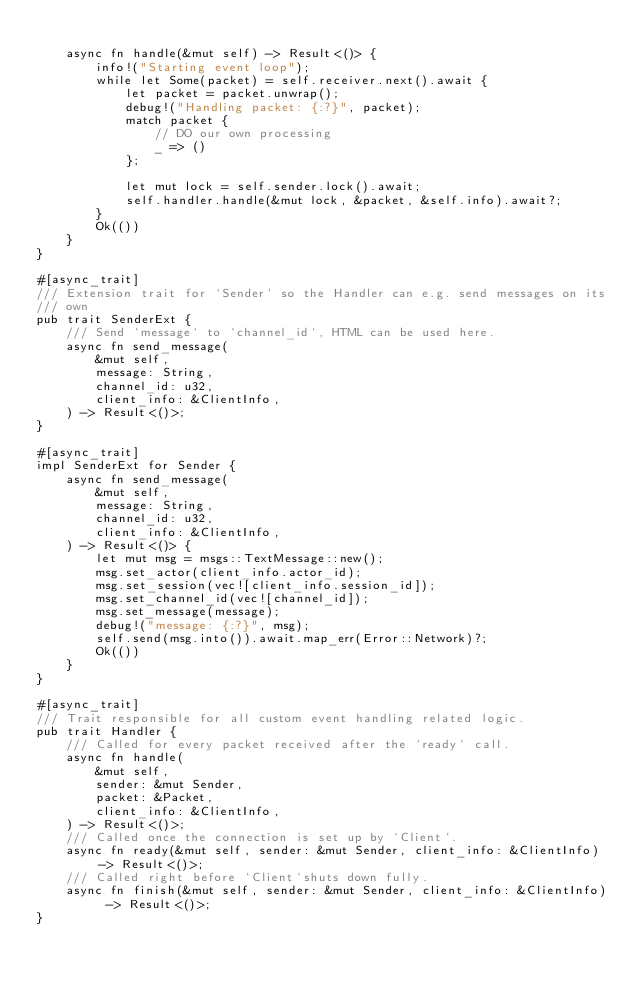<code> <loc_0><loc_0><loc_500><loc_500><_Rust_>
    async fn handle(&mut self) -> Result<()> {
        info!("Starting event loop");
        while let Some(packet) = self.receiver.next().await {
            let packet = packet.unwrap();
            debug!("Handling packet: {:?}", packet);
            match packet {
                // DO our own processing
                _ => ()
            };

            let mut lock = self.sender.lock().await;
            self.handler.handle(&mut lock, &packet, &self.info).await?;
        }
        Ok(())
    }
}

#[async_trait]
/// Extension trait for `Sender` so the Handler can e.g. send messages on its
/// own
pub trait SenderExt {
    /// Send `message` to `channel_id`, HTML can be used here.
    async fn send_message(
        &mut self,
        message: String,
        channel_id: u32,
        client_info: &ClientInfo,
    ) -> Result<()>;
}

#[async_trait]
impl SenderExt for Sender {
    async fn send_message(
        &mut self,
        message: String,
        channel_id: u32,
        client_info: &ClientInfo,
    ) -> Result<()> {
        let mut msg = msgs::TextMessage::new();
        msg.set_actor(client_info.actor_id);
        msg.set_session(vec![client_info.session_id]);
        msg.set_channel_id(vec![channel_id]);
        msg.set_message(message);
        debug!("message: {:?}", msg);
        self.send(msg.into()).await.map_err(Error::Network)?;
        Ok(())
    }
}

#[async_trait]
/// Trait responsible for all custom event handling related logic.
pub trait Handler {
    /// Called for every packet received after the `ready` call.
    async fn handle(
        &mut self,
        sender: &mut Sender,
        packet: &Packet,
        client_info: &ClientInfo,
    ) -> Result<()>;
    /// Called once the connection is set up by `Client`.
    async fn ready(&mut self, sender: &mut Sender, client_info: &ClientInfo) -> Result<()>;
    /// Called right before `Client`shuts down fully.
    async fn finish(&mut self, sender: &mut Sender, client_info: &ClientInfo) -> Result<()>;
}
</code> 